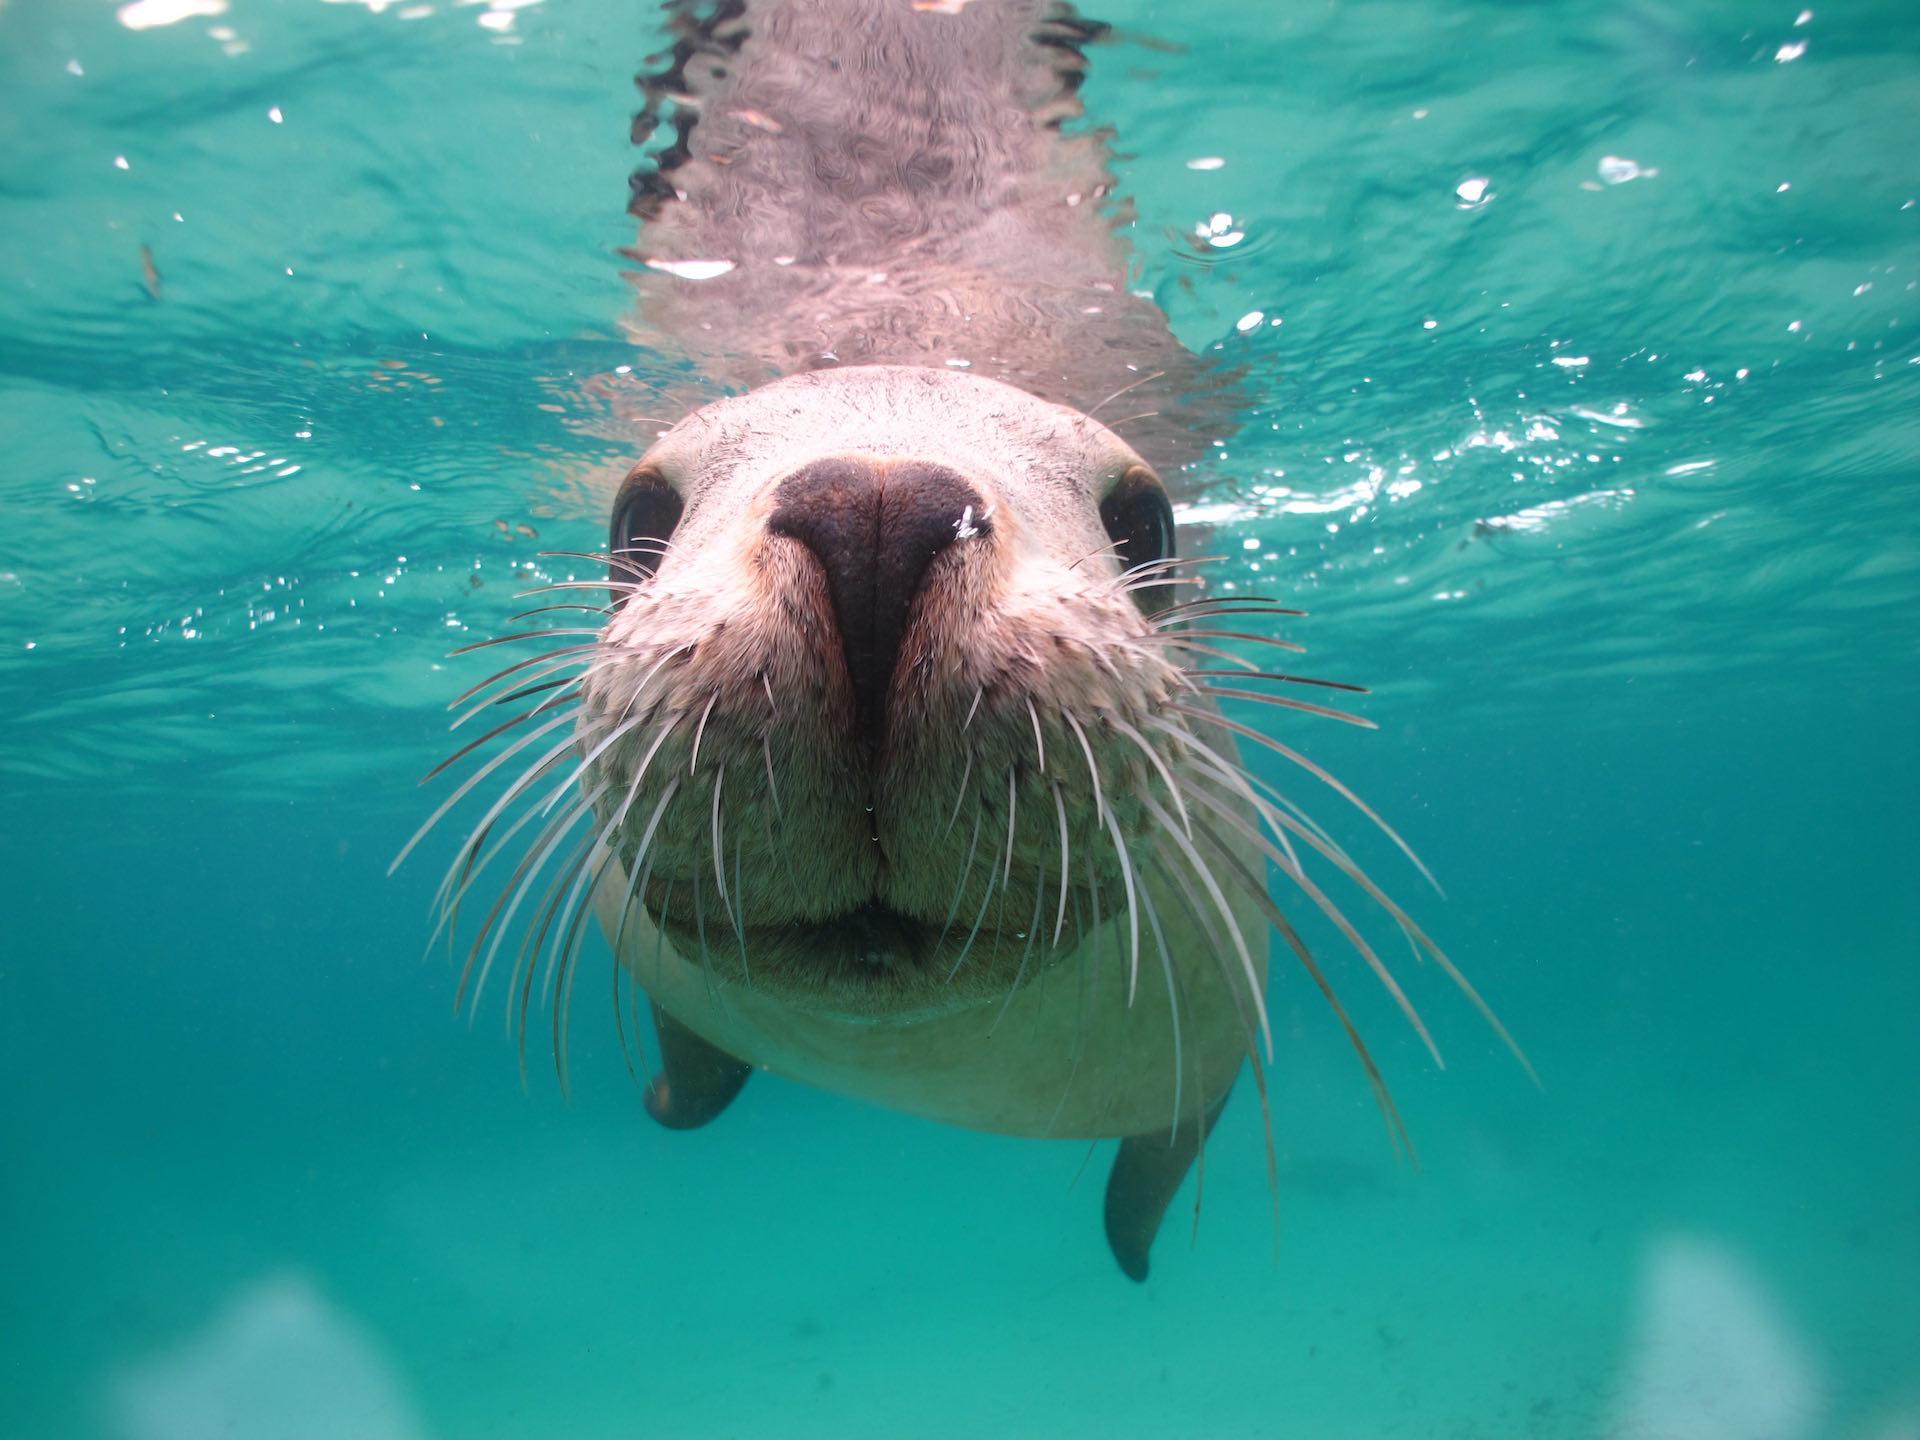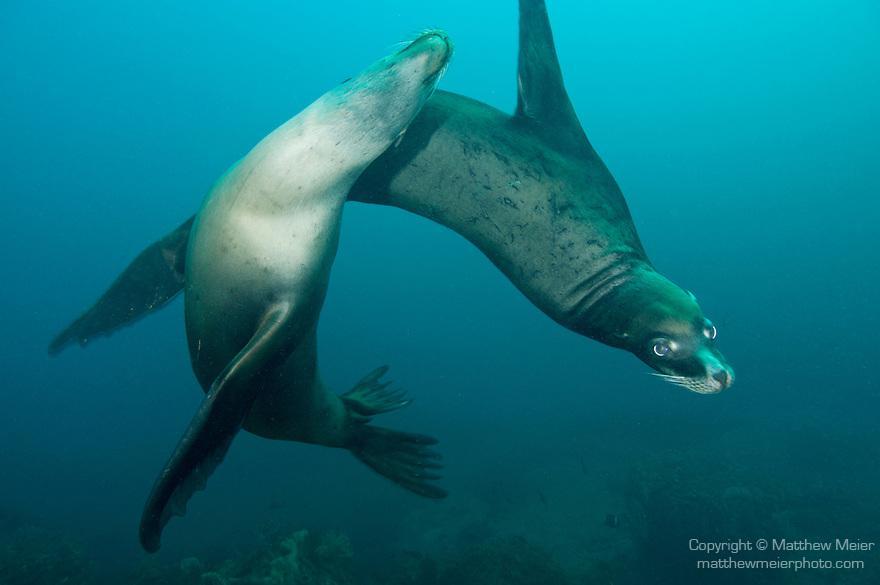The first image is the image on the left, the second image is the image on the right. Assess this claim about the two images: "A single seal is face to face with the camera in the image on the left.". Correct or not? Answer yes or no. Yes. The first image is the image on the left, the second image is the image on the right. Examine the images to the left and right. Is the description "An image shows a camera-facing seal with at least four other seals underwater in the background." accurate? Answer yes or no. No. 